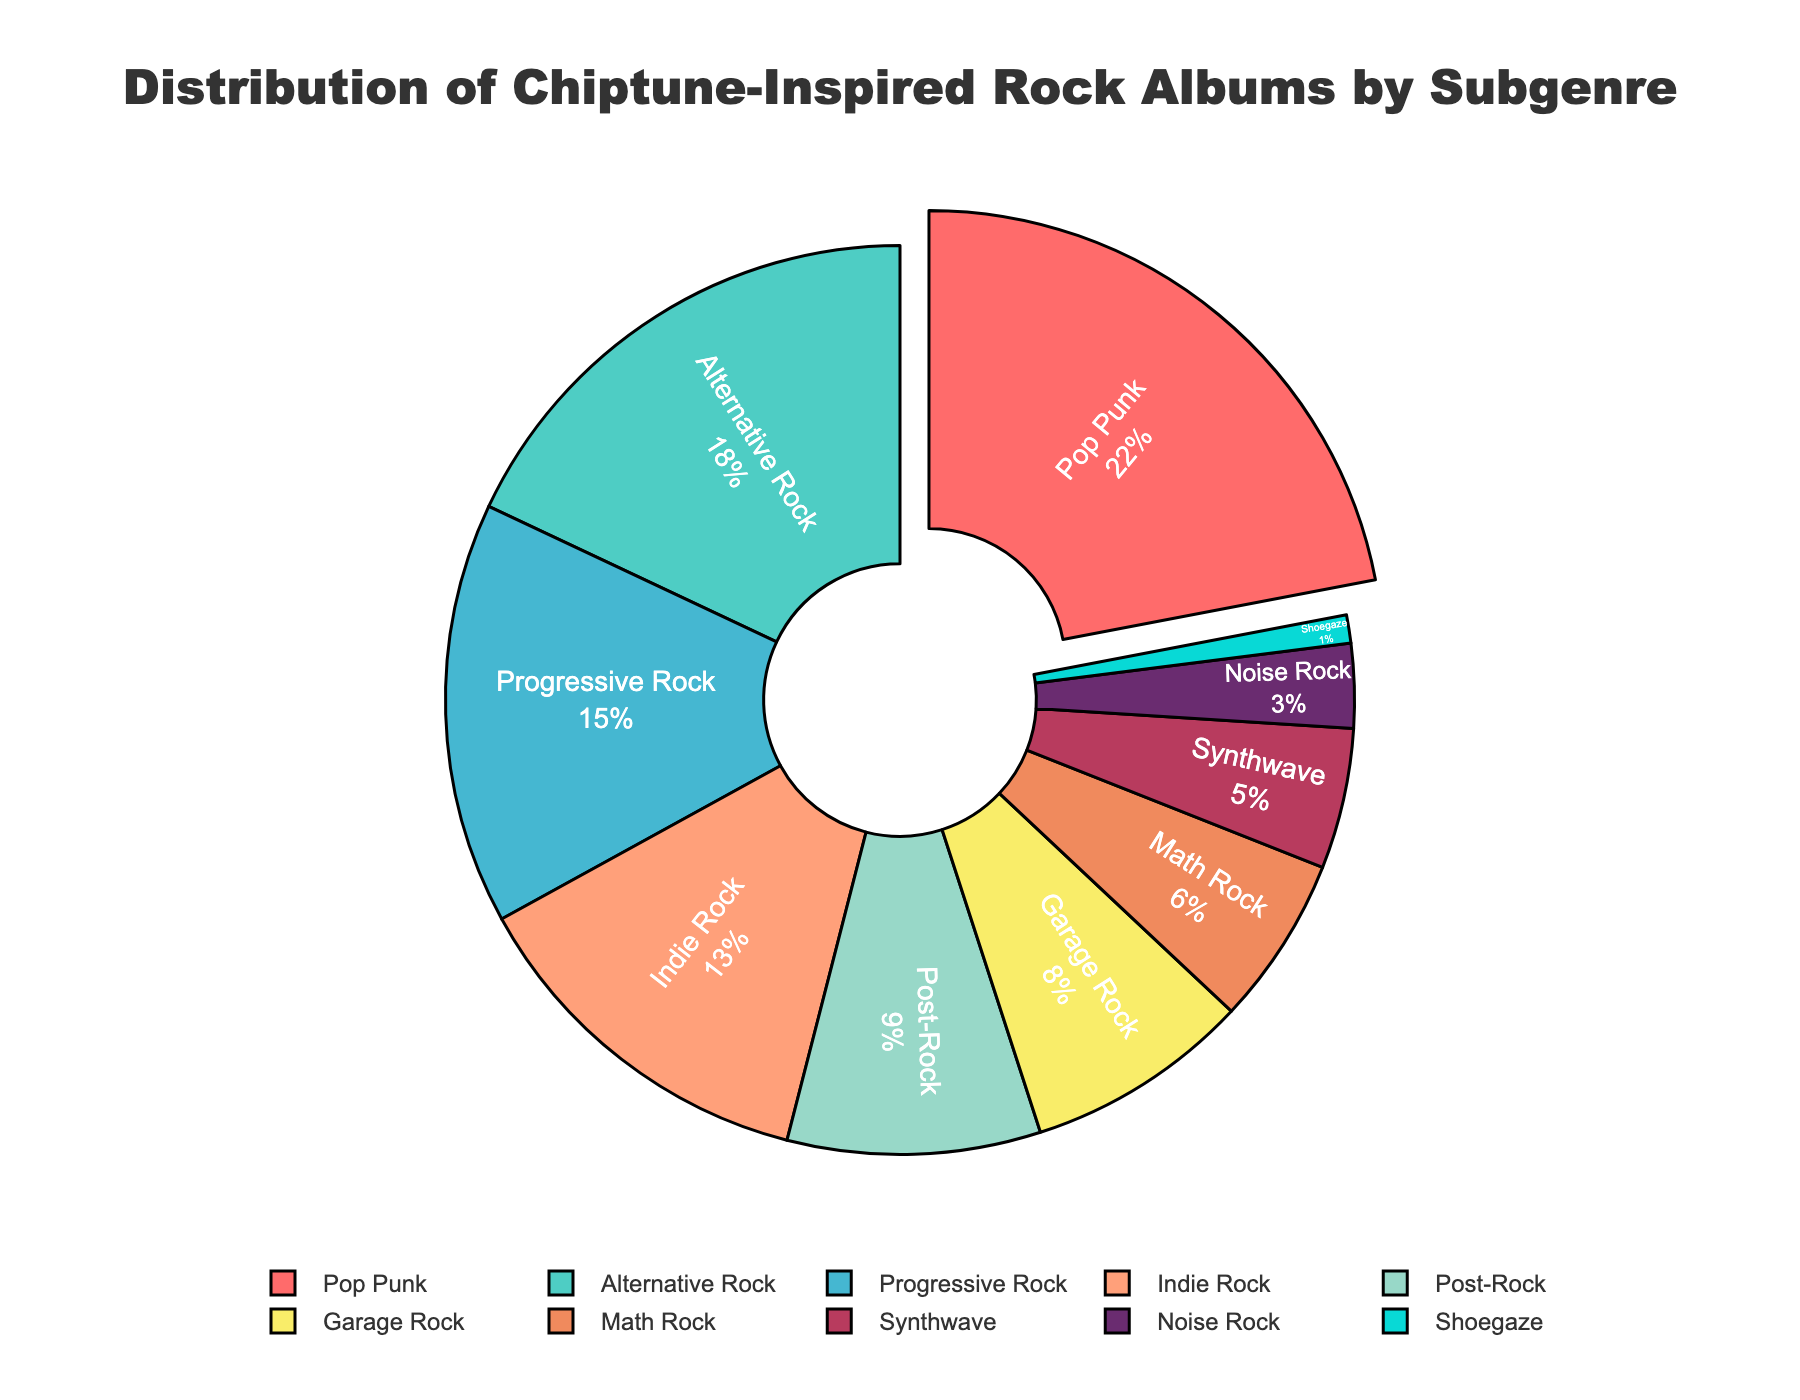what subgenre has the highest percentage? The subgenre with the highest percentage can be identified by looking for the segment that is pulled out of the pie chart and has the largest section. Here, Pop Punk is pulled out because it has the highest percentage at 22%.
Answer: Pop Punk how much more percentage does Alternative Rock have compared to Noise Rock? To determine this, subtract the percentage of Noise Rock from the percentage of Alternative Rock: 18% (Alternative Rock) - 3% (Noise Rock) = 15%.
Answer: 15% what is the combined percentage of Post-Rock and Garage Rock? Add the percentages of Post-Rock and Garage Rock: 9% (Post-Rock) + 8% (Garage Rock) = 17%.
Answer: 17% which subgenre has the smallest percentage and what is it? The subgenre with the smallest percentage can be identified by looking for the smallest segment in the pie chart. Here, Shoegaze is the smallest with 1%.
Answer: Shoegaze, 1% how much less percentage does Synthwave have compared to Progressive Rock? Subtract the percentage of Synthwave from Progressive Rock: 15% (Progressive Rock) - 5% (Synthwave) = 10%.
Answer: 10% what is the average percentage of Indie Rock, Math Rock, and Synthwave? Add the percentages of these subgenres and then divide by the number of subgenres: (13% + 6% + 5%) / 3 = 24% / 3 = 8%.
Answer: 8% how many subgenres have a higher percentage than Indie Rock? Identify and count the subgenres whose percentages are higher than Indie Rock’s 13%. These subgenres are Pop Punk, Alternative Rock, and Progressive Rock, totaling 3.
Answer: 3 what are the subgenres represented by green, blue, and pink colors? Identify the subgenres corresponding to the segments colored green, blue, and pink. Here, green is Alternative Rock, blue is Indie Rock, and pink is Pop Punk.
Answer: Alternative Rock, Indie Rock, Pop Punk what percentage of the albums are in genres with percentages less than 10%? Add the percentages of subgenres with less than 10%: Post-Rock (9%), Garage Rock (8%), Math Rock (6%), Synthwave (5%), Noise Rock (3%), and Shoegaze (1%). 9% + 8% + 6% + 5% + 3% + 1% = 32%.
Answer: 32% how many subgenres are represented in the pie chart? Count the number of unique subgenres listed in the pie chart. Here, there are 10 subgenres listed.
Answer: 10 